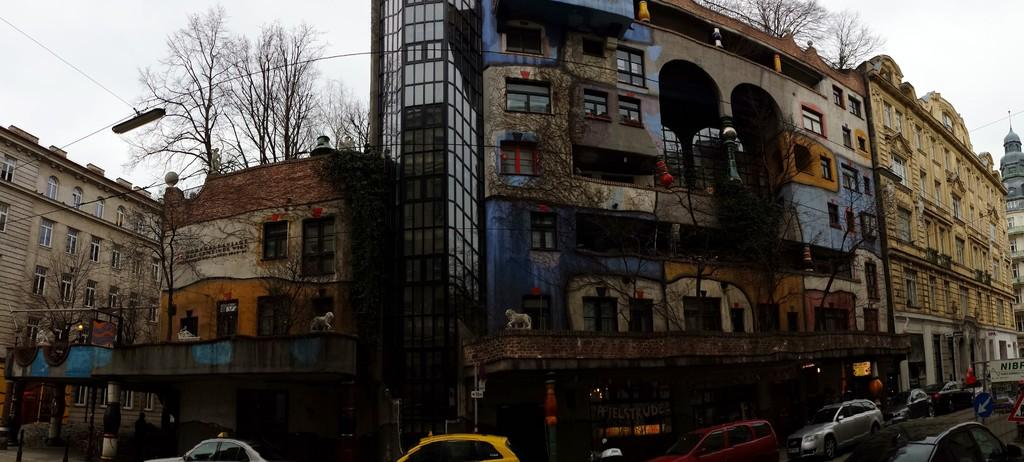What type of structures can be seen in the image? There are buildings with windows in the image. What other natural elements are present in the image? There are trees in the image. What is visible in the background of the image? The sky is visible in the image. What type of transportation can be seen on the road in the image? There are cars on the road in the image. What type of amusement machine can be seen in the image? There is no amusement machine present in the image. What is the base of the buildings made of in the image? The provided facts do not mention the base or material of the buildings, so it cannot be determined from the image. 